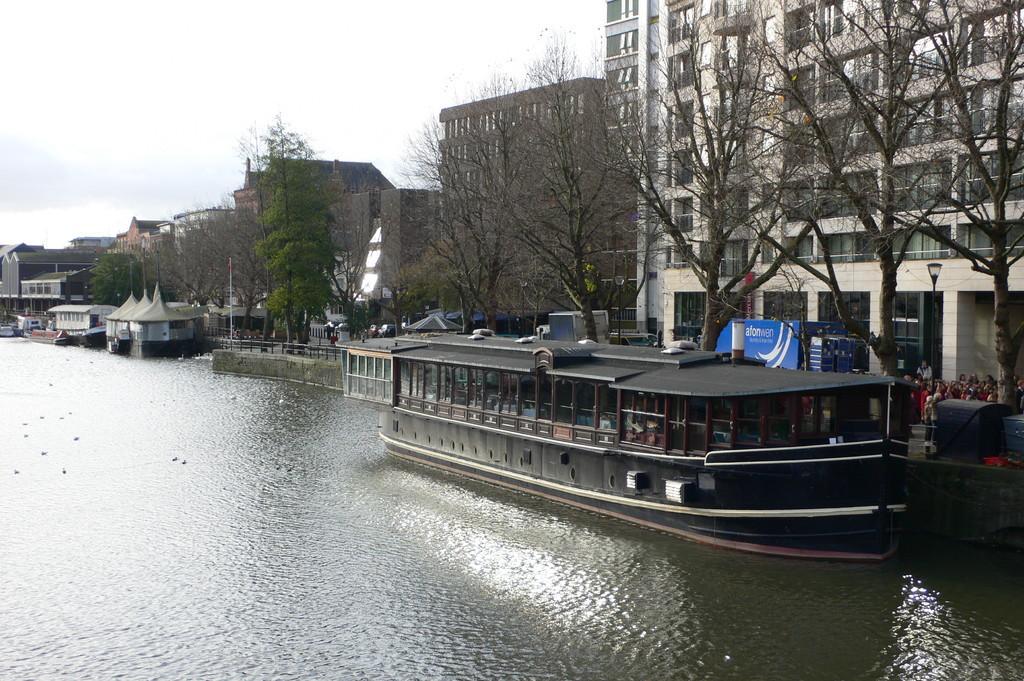Describe this image in one or two sentences. In the center of the image there is a ship on the water. On the right side of the image we can see building, person's, vehicle, light pole and trees. On the left side we can see buildings, vehicles, tents, trees and fencing. At the bottom there is a water. In the background we can see sky and clouds. 